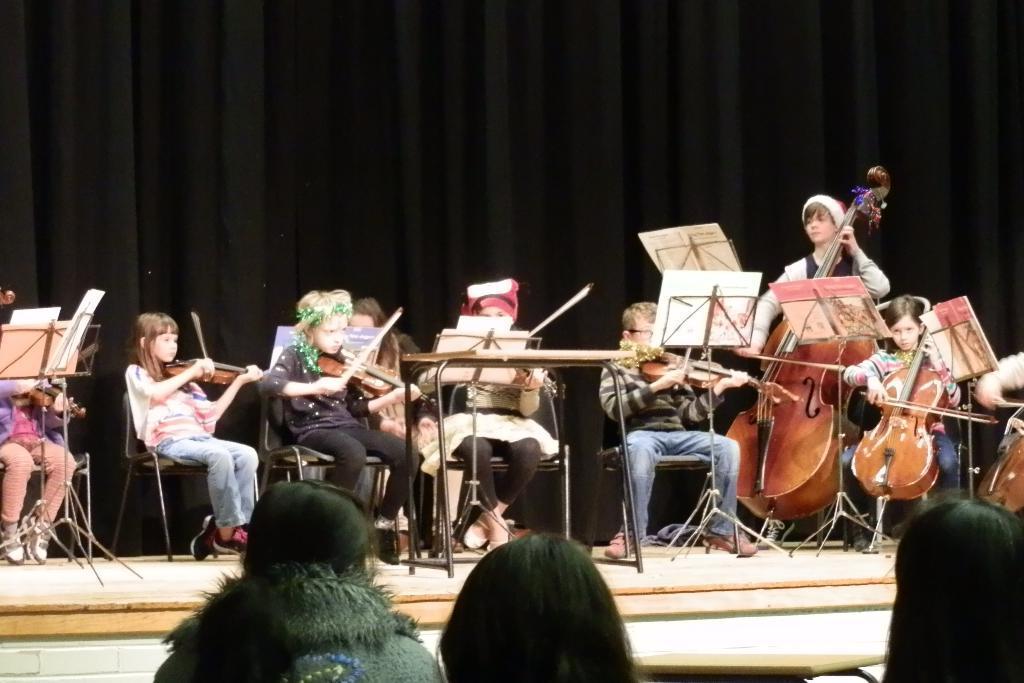Describe this image in one or two sentences. In this picture we can see a group of people on the chairs on the stage holding some musical instruments and playing them and the background is black in color. 